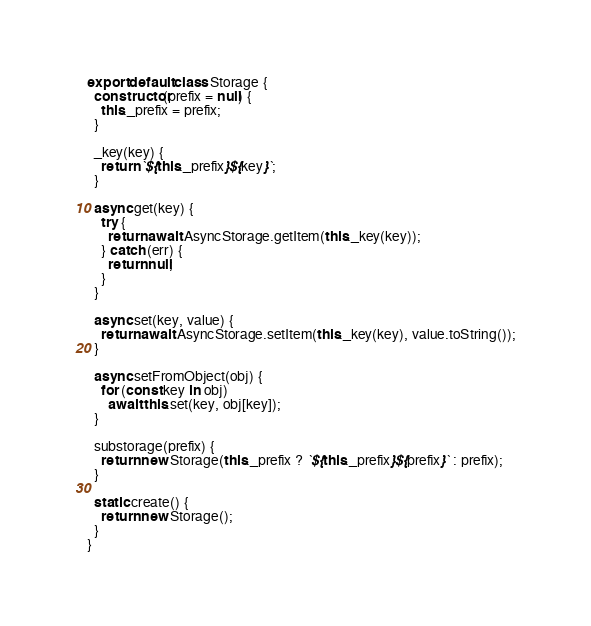<code> <loc_0><loc_0><loc_500><loc_500><_JavaScript_>

export default class Storage {
  constructor(prefix = null) {
    this._prefix = prefix;
  }

  _key(key) {
    return `${this._prefix}${key}`;
  }

  async get(key) {
    try {
      return await AsyncStorage.getItem(this._key(key));
    } catch (err) {
      return null;
    }
  }

  async set(key, value) {
    return await AsyncStorage.setItem(this._key(key), value.toString());
  }

  async setFromObject(obj) {
    for (const key in obj)
      await this.set(key, obj[key]);
  }

  substorage(prefix) {
    return new Storage(this._prefix ? `${this._prefix}${prefix}` : prefix);
  }

  static create() {
    return new Storage();
  }
}
</code> 